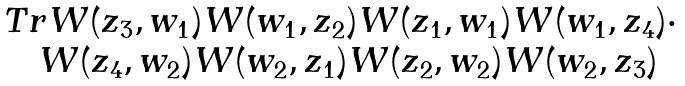<formula> <loc_0><loc_0><loc_500><loc_500>\begin{array} { r l } & T r W ( z _ { 3 } , w _ { 1 } ) W ( w _ { 1 } , z _ { 2 } ) W ( z _ { 1 } , w _ { 1 } ) W ( w _ { 1 } , z _ { 4 } ) \cdot \\ & \quad W ( z _ { 4 } , w _ { 2 } ) W ( w _ { 2 } , z _ { 1 } ) W ( z _ { 2 } , w _ { 2 } ) W ( w _ { 2 } , z _ { 3 } ) \end{array}</formula> 